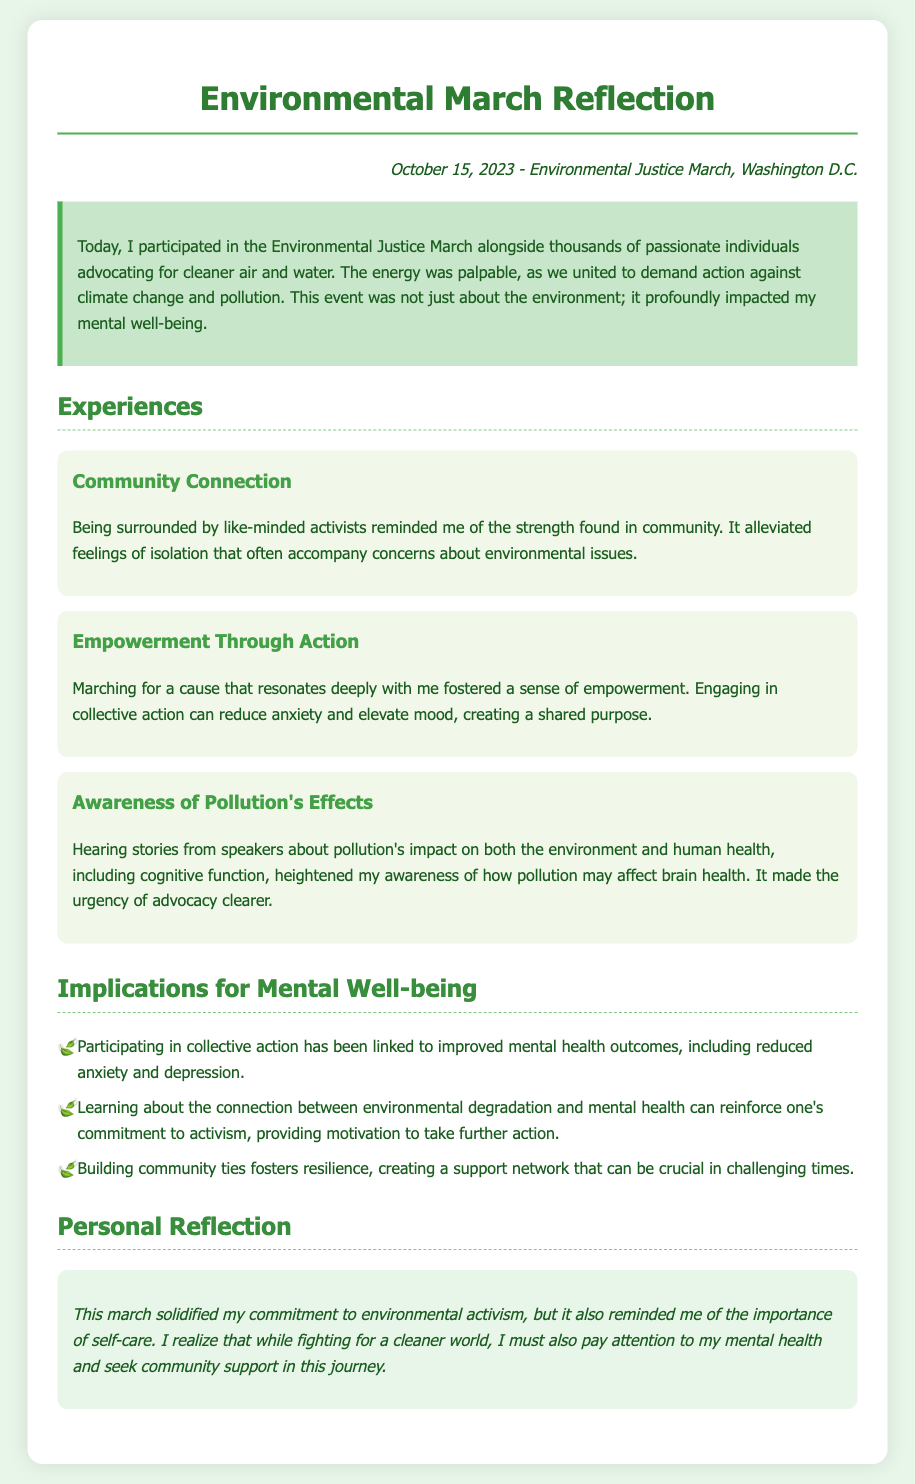What is the date of the Environmental Justice March? The date of the Environmental Justice March is mentioned in the document as October 15, 2023.
Answer: October 15, 2023 What city hosted the Environmental Justice March? The city where the Environmental Justice March took place is specified in the document as Washington D.C.
Answer: Washington D.C What is one effect of participating in collective action, according to the document? The document states that participating in collective action has been linked to improved mental health outcomes, such as reduced anxiety and depression.
Answer: Reduced anxiety What is the main theme of the personal reflection at the end of the document? The personal reflection emphasizes the importance of balancing environmental activism with self-care and mental health.
Answer: Self-care Which aspect of the march heightened awareness regarding brain health? The march featured speakers discussing the impact of pollution on both the environment and human health, including cognitive function, which heightened awareness.
Answer: Pollution's impact on cognitive function What did the community connection during the march alleviate? The document mentions that being surrounded by like-minded activists alleviated feelings of isolation.
Answer: Feelings of isolation What color represents the section highlighting experiences? The section highlighting experiences is represented by a background color described in the document.
Answer: Light green How many experiences are listed in the document? The document lists three distinct experiences related to the march.
Answer: Three 